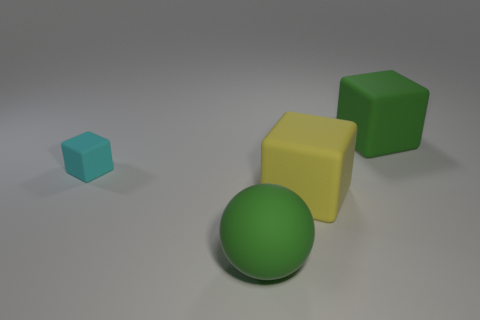The object that is the same color as the ball is what size?
Ensure brevity in your answer.  Large. What number of big matte objects have the same color as the matte sphere?
Offer a very short reply. 1. What number of other green matte objects have the same shape as the tiny rubber object?
Ensure brevity in your answer.  1. What material is the sphere?
Keep it short and to the point. Rubber. Is the tiny thing the same shape as the big yellow rubber object?
Offer a terse response. Yes. Are there any balls made of the same material as the cyan object?
Offer a terse response. Yes. What color is the large matte object that is in front of the tiny cyan rubber block and behind the big sphere?
Keep it short and to the point. Yellow. There is a big block that is behind the tiny matte object; what is it made of?
Make the answer very short. Rubber. Are there any green matte objects of the same shape as the cyan thing?
Provide a short and direct response. Yes. What number of other things are the same shape as the tiny cyan object?
Make the answer very short. 2. 